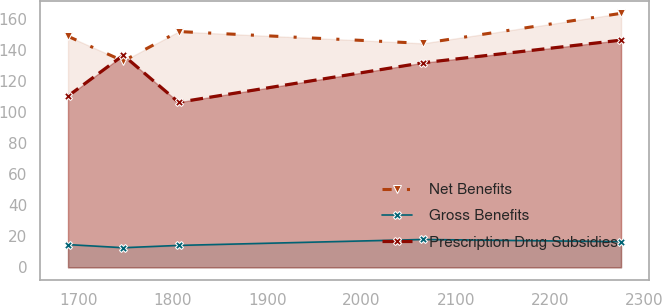Convert chart to OTSL. <chart><loc_0><loc_0><loc_500><loc_500><line_chart><ecel><fcel>Net Benefits<fcel>Gross Benefits<fcel>Prescription Drug Subsidies<nl><fcel>1688.75<fcel>148.68<fcel>14.66<fcel>110.24<nl><fcel>1747.41<fcel>132.8<fcel>12.65<fcel>136.52<nl><fcel>1806.07<fcel>151.75<fcel>14.13<fcel>106.24<nl><fcel>2065.23<fcel>144.15<fcel>17.95<fcel>131.66<nl><fcel>2275.38<fcel>163.46<fcel>16.53<fcel>146.22<nl></chart> 